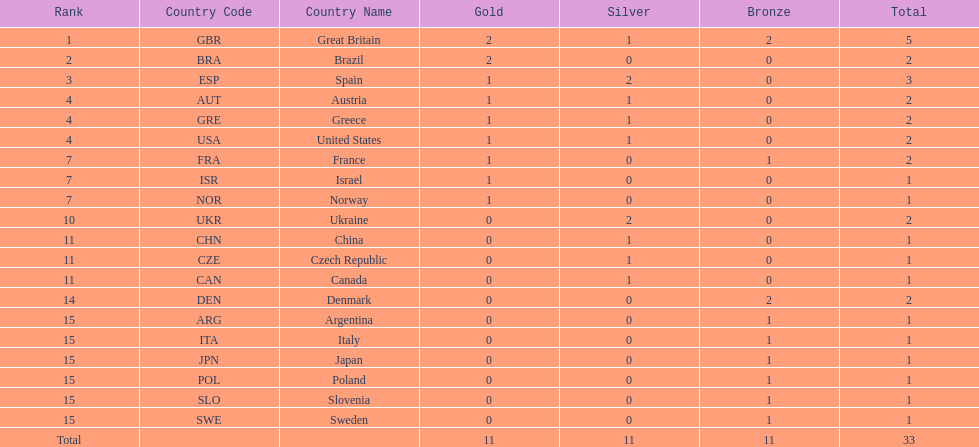What nation was next to great britain in total medal count? Spain. 